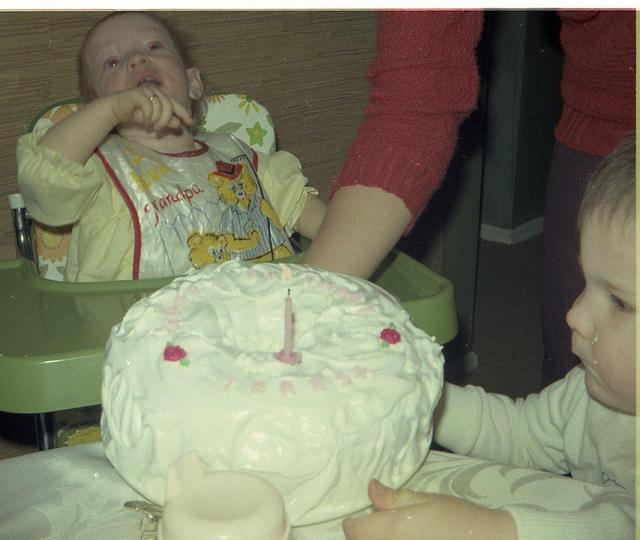Why is there a candle in the cake? Please explain your reasoning. to celebrate. This is for the childs birthday celebration. 